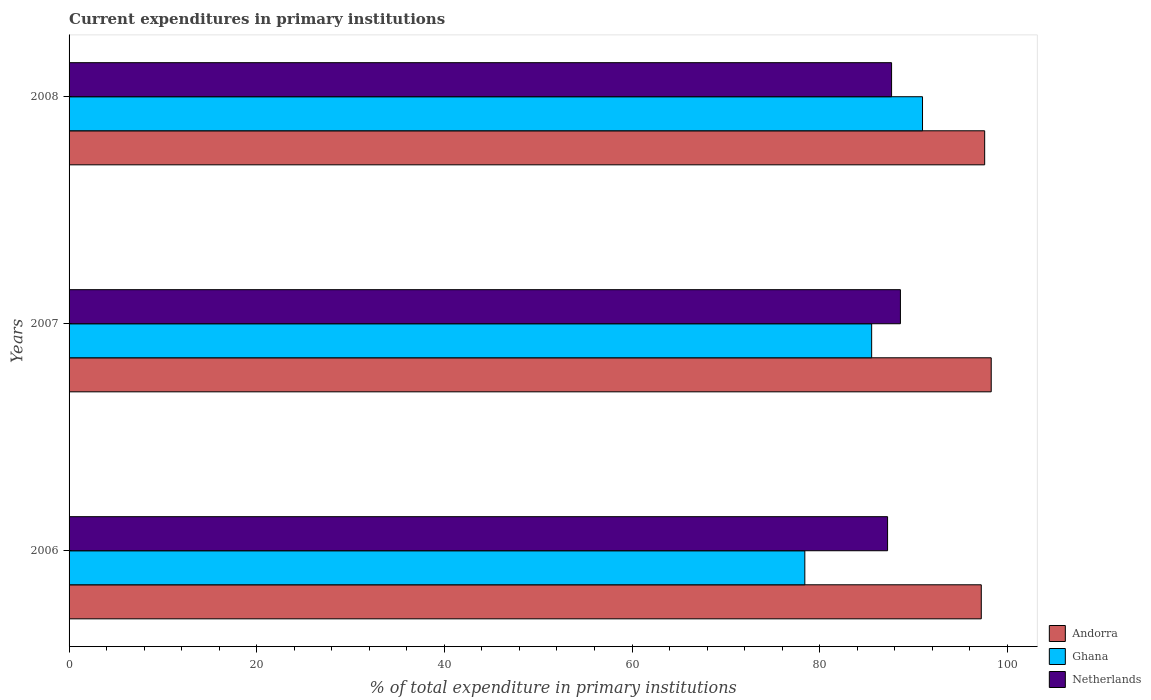How many bars are there on the 2nd tick from the top?
Ensure brevity in your answer.  3. What is the current expenditures in primary institutions in Andorra in 2007?
Offer a terse response. 98.28. Across all years, what is the maximum current expenditures in primary institutions in Ghana?
Keep it short and to the point. 90.96. Across all years, what is the minimum current expenditures in primary institutions in Andorra?
Your answer should be compact. 97.23. In which year was the current expenditures in primary institutions in Andorra minimum?
Offer a very short reply. 2006. What is the total current expenditures in primary institutions in Ghana in the graph?
Make the answer very short. 254.93. What is the difference between the current expenditures in primary institutions in Ghana in 2006 and that in 2007?
Keep it short and to the point. -7.12. What is the difference between the current expenditures in primary institutions in Andorra in 2006 and the current expenditures in primary institutions in Ghana in 2007?
Provide a short and direct response. 11.68. What is the average current expenditures in primary institutions in Ghana per year?
Your answer should be very brief. 84.98. In the year 2006, what is the difference between the current expenditures in primary institutions in Ghana and current expenditures in primary institutions in Netherlands?
Your response must be concise. -8.82. What is the ratio of the current expenditures in primary institutions in Ghana in 2007 to that in 2008?
Make the answer very short. 0.94. What is the difference between the highest and the second highest current expenditures in primary institutions in Ghana?
Keep it short and to the point. 5.42. What is the difference between the highest and the lowest current expenditures in primary institutions in Andorra?
Give a very brief answer. 1.06. What does the 3rd bar from the top in 2006 represents?
Provide a succinct answer. Andorra. What does the 2nd bar from the bottom in 2006 represents?
Your answer should be very brief. Ghana. Is it the case that in every year, the sum of the current expenditures in primary institutions in Netherlands and current expenditures in primary institutions in Ghana is greater than the current expenditures in primary institutions in Andorra?
Provide a succinct answer. Yes. What is the difference between two consecutive major ticks on the X-axis?
Your answer should be compact. 20. Are the values on the major ticks of X-axis written in scientific E-notation?
Give a very brief answer. No. Where does the legend appear in the graph?
Your response must be concise. Bottom right. What is the title of the graph?
Provide a short and direct response. Current expenditures in primary institutions. What is the label or title of the X-axis?
Ensure brevity in your answer.  % of total expenditure in primary institutions. What is the % of total expenditure in primary institutions in Andorra in 2006?
Your answer should be very brief. 97.23. What is the % of total expenditure in primary institutions of Ghana in 2006?
Provide a succinct answer. 78.42. What is the % of total expenditure in primary institutions in Netherlands in 2006?
Keep it short and to the point. 87.24. What is the % of total expenditure in primary institutions in Andorra in 2007?
Give a very brief answer. 98.28. What is the % of total expenditure in primary institutions of Ghana in 2007?
Provide a succinct answer. 85.54. What is the % of total expenditure in primary institutions in Netherlands in 2007?
Make the answer very short. 88.61. What is the % of total expenditure in primary institutions of Andorra in 2008?
Your response must be concise. 97.59. What is the % of total expenditure in primary institutions of Ghana in 2008?
Provide a succinct answer. 90.96. What is the % of total expenditure in primary institutions in Netherlands in 2008?
Ensure brevity in your answer.  87.67. Across all years, what is the maximum % of total expenditure in primary institutions of Andorra?
Make the answer very short. 98.28. Across all years, what is the maximum % of total expenditure in primary institutions of Ghana?
Your answer should be compact. 90.96. Across all years, what is the maximum % of total expenditure in primary institutions of Netherlands?
Ensure brevity in your answer.  88.61. Across all years, what is the minimum % of total expenditure in primary institutions of Andorra?
Provide a succinct answer. 97.23. Across all years, what is the minimum % of total expenditure in primary institutions of Ghana?
Ensure brevity in your answer.  78.42. Across all years, what is the minimum % of total expenditure in primary institutions of Netherlands?
Provide a succinct answer. 87.24. What is the total % of total expenditure in primary institutions in Andorra in the graph?
Keep it short and to the point. 293.1. What is the total % of total expenditure in primary institutions of Ghana in the graph?
Offer a terse response. 254.93. What is the total % of total expenditure in primary institutions of Netherlands in the graph?
Offer a terse response. 263.51. What is the difference between the % of total expenditure in primary institutions in Andorra in 2006 and that in 2007?
Provide a succinct answer. -1.06. What is the difference between the % of total expenditure in primary institutions of Ghana in 2006 and that in 2007?
Offer a terse response. -7.12. What is the difference between the % of total expenditure in primary institutions in Netherlands in 2006 and that in 2007?
Offer a very short reply. -1.37. What is the difference between the % of total expenditure in primary institutions of Andorra in 2006 and that in 2008?
Your answer should be very brief. -0.36. What is the difference between the % of total expenditure in primary institutions in Ghana in 2006 and that in 2008?
Your answer should be very brief. -12.54. What is the difference between the % of total expenditure in primary institutions of Netherlands in 2006 and that in 2008?
Provide a short and direct response. -0.43. What is the difference between the % of total expenditure in primary institutions in Andorra in 2007 and that in 2008?
Provide a short and direct response. 0.7. What is the difference between the % of total expenditure in primary institutions in Ghana in 2007 and that in 2008?
Keep it short and to the point. -5.42. What is the difference between the % of total expenditure in primary institutions of Netherlands in 2007 and that in 2008?
Offer a terse response. 0.94. What is the difference between the % of total expenditure in primary institutions of Andorra in 2006 and the % of total expenditure in primary institutions of Ghana in 2007?
Offer a very short reply. 11.68. What is the difference between the % of total expenditure in primary institutions of Andorra in 2006 and the % of total expenditure in primary institutions of Netherlands in 2007?
Provide a short and direct response. 8.62. What is the difference between the % of total expenditure in primary institutions in Ghana in 2006 and the % of total expenditure in primary institutions in Netherlands in 2007?
Your answer should be very brief. -10.19. What is the difference between the % of total expenditure in primary institutions in Andorra in 2006 and the % of total expenditure in primary institutions in Ghana in 2008?
Your answer should be very brief. 6.26. What is the difference between the % of total expenditure in primary institutions in Andorra in 2006 and the % of total expenditure in primary institutions in Netherlands in 2008?
Offer a terse response. 9.56. What is the difference between the % of total expenditure in primary institutions in Ghana in 2006 and the % of total expenditure in primary institutions in Netherlands in 2008?
Give a very brief answer. -9.25. What is the difference between the % of total expenditure in primary institutions in Andorra in 2007 and the % of total expenditure in primary institutions in Ghana in 2008?
Your response must be concise. 7.32. What is the difference between the % of total expenditure in primary institutions in Andorra in 2007 and the % of total expenditure in primary institutions in Netherlands in 2008?
Provide a short and direct response. 10.62. What is the difference between the % of total expenditure in primary institutions in Ghana in 2007 and the % of total expenditure in primary institutions in Netherlands in 2008?
Offer a terse response. -2.12. What is the average % of total expenditure in primary institutions of Andorra per year?
Provide a succinct answer. 97.7. What is the average % of total expenditure in primary institutions in Ghana per year?
Your response must be concise. 84.97. What is the average % of total expenditure in primary institutions of Netherlands per year?
Offer a terse response. 87.84. In the year 2006, what is the difference between the % of total expenditure in primary institutions of Andorra and % of total expenditure in primary institutions of Ghana?
Your response must be concise. 18.81. In the year 2006, what is the difference between the % of total expenditure in primary institutions of Andorra and % of total expenditure in primary institutions of Netherlands?
Provide a succinct answer. 9.99. In the year 2006, what is the difference between the % of total expenditure in primary institutions of Ghana and % of total expenditure in primary institutions of Netherlands?
Make the answer very short. -8.82. In the year 2007, what is the difference between the % of total expenditure in primary institutions in Andorra and % of total expenditure in primary institutions in Ghana?
Your response must be concise. 12.74. In the year 2007, what is the difference between the % of total expenditure in primary institutions of Andorra and % of total expenditure in primary institutions of Netherlands?
Offer a terse response. 9.68. In the year 2007, what is the difference between the % of total expenditure in primary institutions in Ghana and % of total expenditure in primary institutions in Netherlands?
Offer a very short reply. -3.06. In the year 2008, what is the difference between the % of total expenditure in primary institutions of Andorra and % of total expenditure in primary institutions of Ghana?
Provide a succinct answer. 6.63. In the year 2008, what is the difference between the % of total expenditure in primary institutions in Andorra and % of total expenditure in primary institutions in Netherlands?
Give a very brief answer. 9.92. In the year 2008, what is the difference between the % of total expenditure in primary institutions of Ghana and % of total expenditure in primary institutions of Netherlands?
Offer a very short reply. 3.3. What is the ratio of the % of total expenditure in primary institutions in Netherlands in 2006 to that in 2007?
Your answer should be compact. 0.98. What is the ratio of the % of total expenditure in primary institutions in Ghana in 2006 to that in 2008?
Keep it short and to the point. 0.86. What is the ratio of the % of total expenditure in primary institutions in Netherlands in 2006 to that in 2008?
Your answer should be compact. 1. What is the ratio of the % of total expenditure in primary institutions of Andorra in 2007 to that in 2008?
Keep it short and to the point. 1.01. What is the ratio of the % of total expenditure in primary institutions in Ghana in 2007 to that in 2008?
Make the answer very short. 0.94. What is the ratio of the % of total expenditure in primary institutions in Netherlands in 2007 to that in 2008?
Your answer should be compact. 1.01. What is the difference between the highest and the second highest % of total expenditure in primary institutions in Andorra?
Ensure brevity in your answer.  0.7. What is the difference between the highest and the second highest % of total expenditure in primary institutions of Ghana?
Provide a succinct answer. 5.42. What is the difference between the highest and the second highest % of total expenditure in primary institutions in Netherlands?
Your response must be concise. 0.94. What is the difference between the highest and the lowest % of total expenditure in primary institutions in Andorra?
Provide a succinct answer. 1.06. What is the difference between the highest and the lowest % of total expenditure in primary institutions of Ghana?
Your answer should be very brief. 12.54. What is the difference between the highest and the lowest % of total expenditure in primary institutions in Netherlands?
Provide a succinct answer. 1.37. 